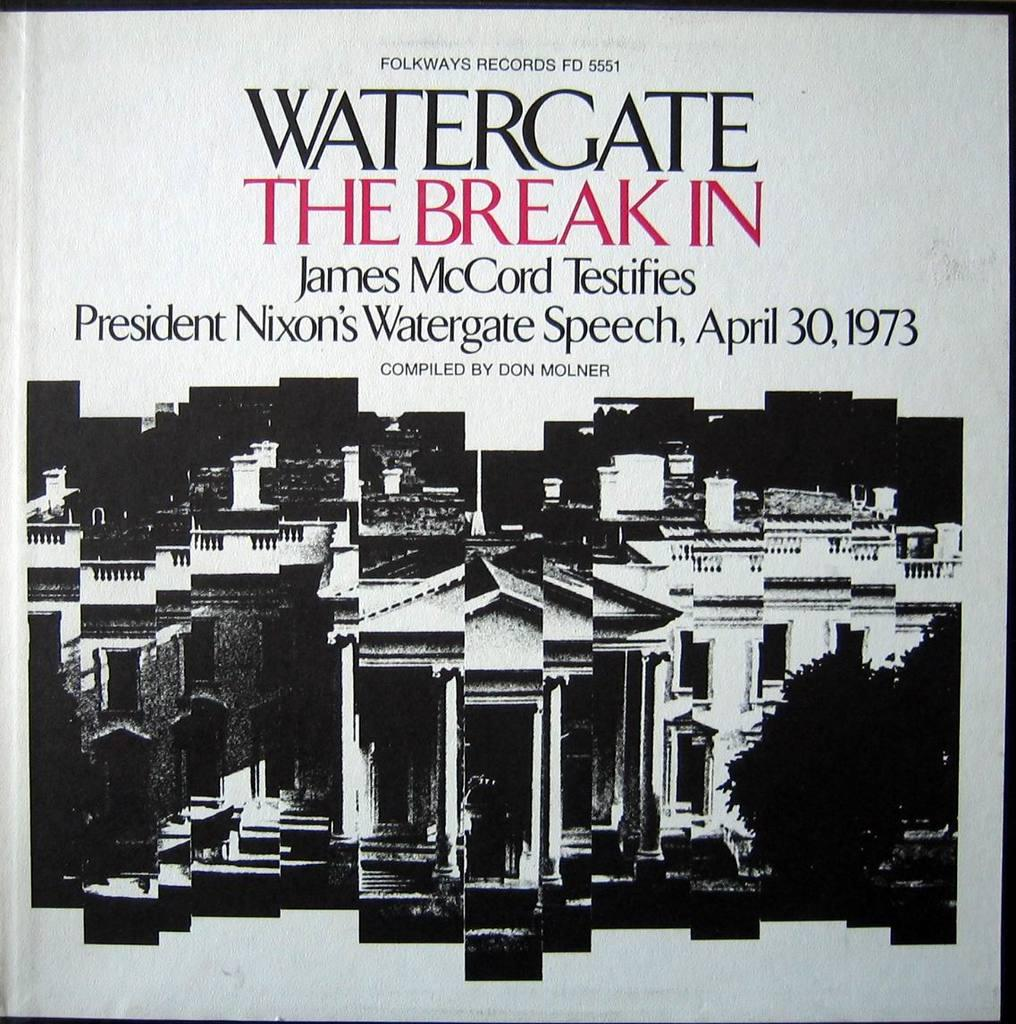What is the main subject of the poster in the image? The poster includes images of buildings and trees. Are there any other elements on the poster besides the images? Yes, there is text written on the poster. How many leaves can be seen on the poster? There is no mention of leaves on the poster; it includes images of buildings and trees, but not individual leaves. 